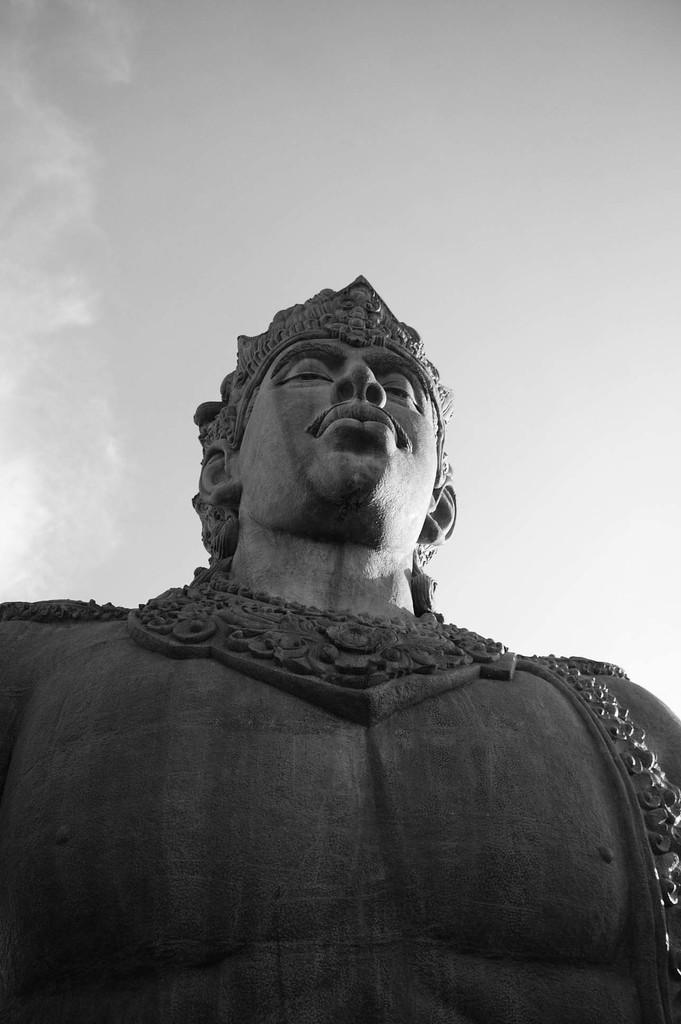What is the main subject in the center of the image? There is a statue in the center of the image. What is the color of the statue? The statue is black in color. What can be seen in the background of the image? There is sky visible in the background of the image, and clouds are present. Reasoning: Let's think step by step by step in order to produce the conversation. We start by identifying the main subject in the image, which is the statue. Then, we describe the statue's color, which is black. Finally, we mention the background of the image, which includes the sky and clouds. Each question is designed to elicit a specific detail about the image that is known from the provided facts. Absurd Question/Answer: How many cows are standing next to the statue in the image? There are no cows present in the image; it features a black statue with a sky and cloud background. What type of rock is the statue made of in the image? The provided facts do not mention the material the statue is made of, so it cannot be determined from the image. 